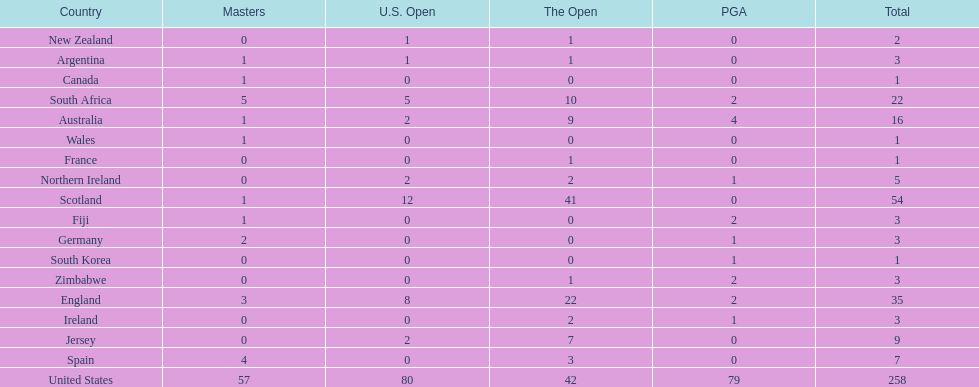How many countries have produced the same number of championship golfers as canada? 3. 